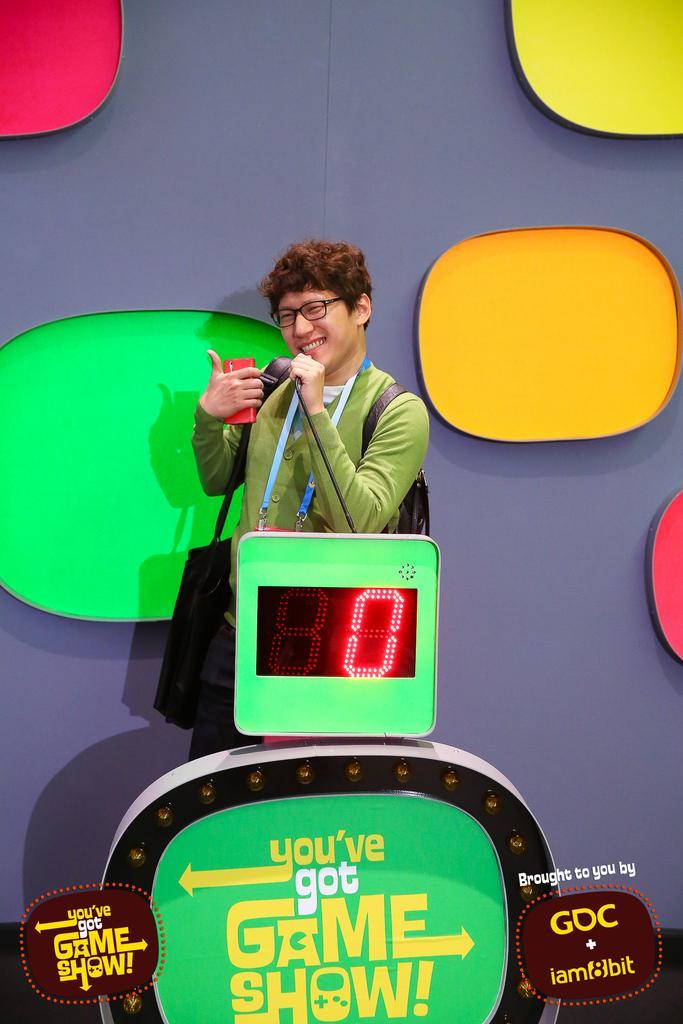Could you give a brief overview of what you see in this image? In the center of the image we can see a man is standing and wearing T-shirt, id card, bag and holding a mobile. At the bottom of the image we can see a display board, board and text. In the background of the image we can see the different colors on the wall. 